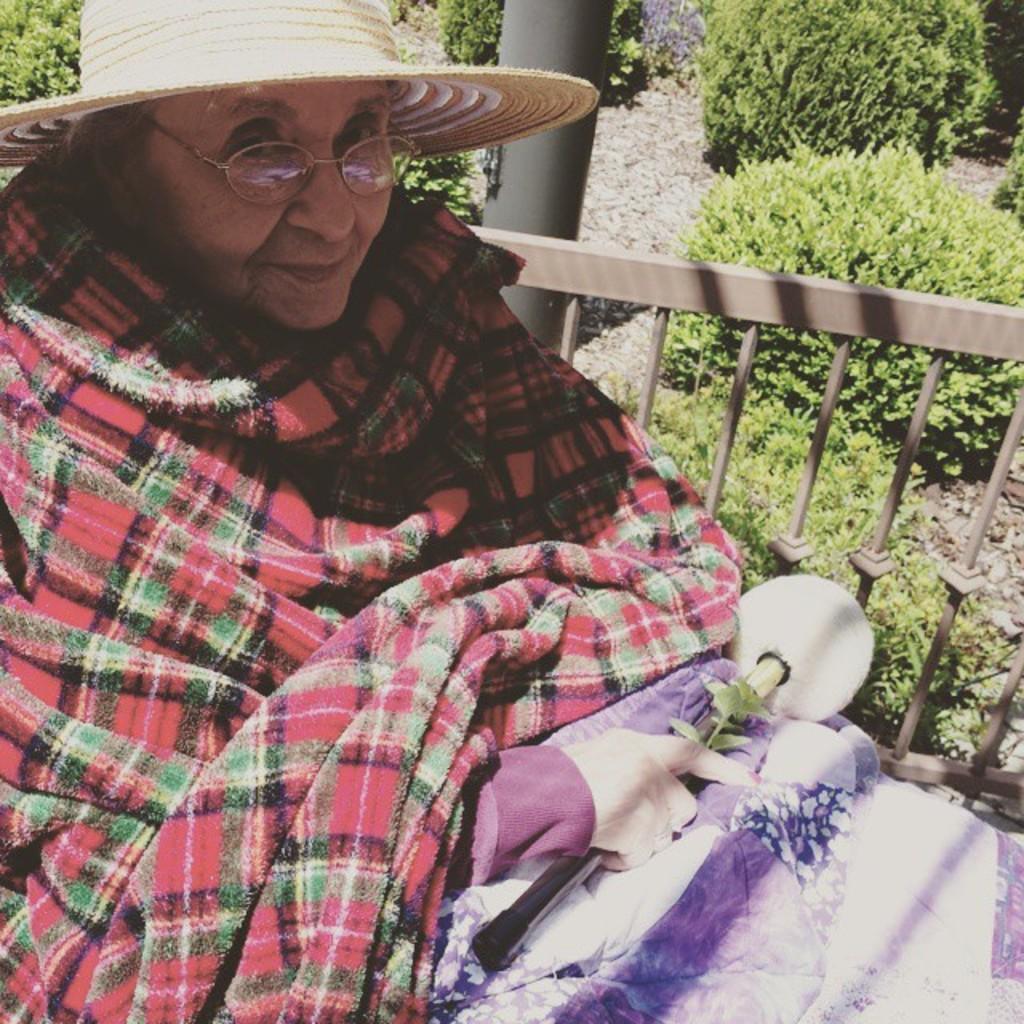Please provide a concise description of this image. In this image we can see a woman wearing a cap and holding an object and behind her we can see a fence, pole and plants. 